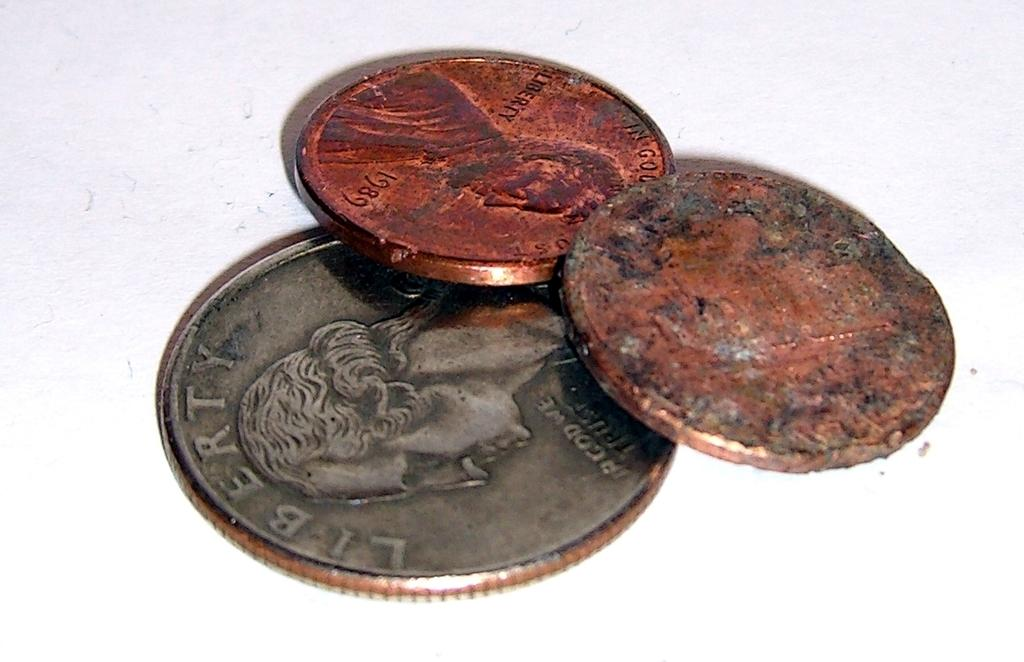<image>
Share a concise interpretation of the image provided. A 1989 penny is among the three coins. 